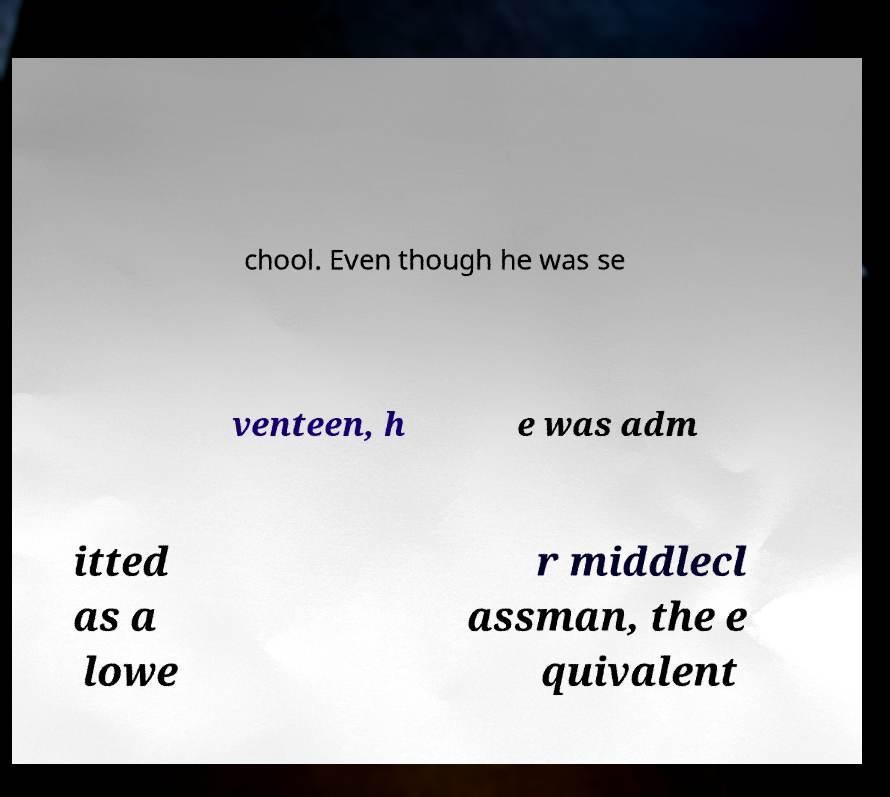For documentation purposes, I need the text within this image transcribed. Could you provide that? chool. Even though he was se venteen, h e was adm itted as a lowe r middlecl assman, the e quivalent 